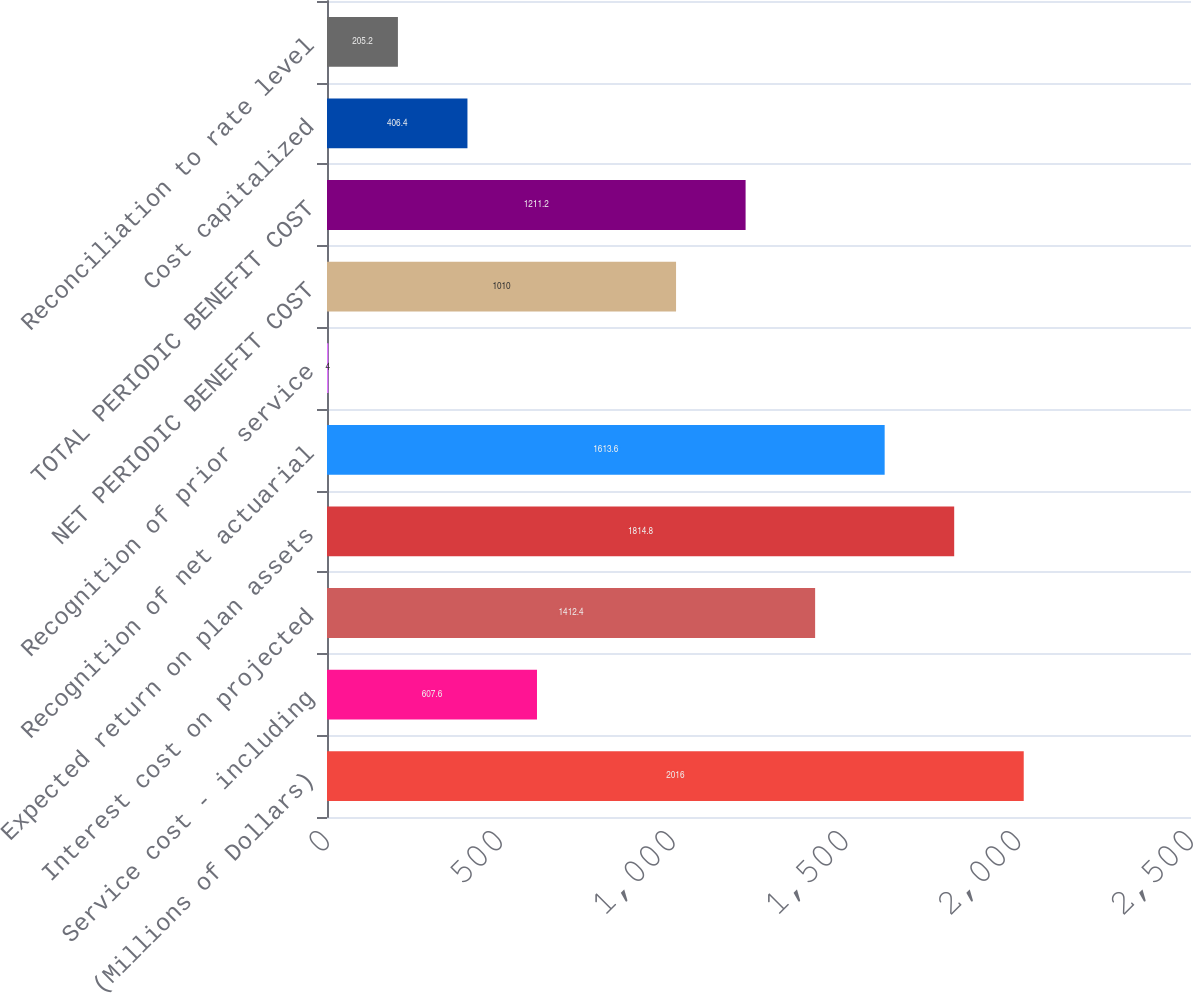Convert chart to OTSL. <chart><loc_0><loc_0><loc_500><loc_500><bar_chart><fcel>(Millions of Dollars)<fcel>Service cost - including<fcel>Interest cost on projected<fcel>Expected return on plan assets<fcel>Recognition of net actuarial<fcel>Recognition of prior service<fcel>NET PERIODIC BENEFIT COST<fcel>TOTAL PERIODIC BENEFIT COST<fcel>Cost capitalized<fcel>Reconciliation to rate level<nl><fcel>2016<fcel>607.6<fcel>1412.4<fcel>1814.8<fcel>1613.6<fcel>4<fcel>1010<fcel>1211.2<fcel>406.4<fcel>205.2<nl></chart> 